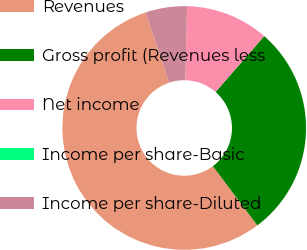<chart> <loc_0><loc_0><loc_500><loc_500><pie_chart><fcel>Revenues<fcel>Gross profit (Revenues less<fcel>Net income<fcel>Income per share-Basic<fcel>Income per share-Diluted<nl><fcel>55.12%<fcel>28.35%<fcel>11.02%<fcel>0.0%<fcel>5.51%<nl></chart> 